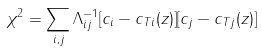Convert formula to latex. <formula><loc_0><loc_0><loc_500><loc_500>\chi ^ { 2 } = \sum _ { i , j } \Lambda _ { i j } ^ { - 1 } [ c _ { i } - c _ { T i } ( z ) ] [ c _ { j } - c _ { T j } ( z ) ]</formula> 